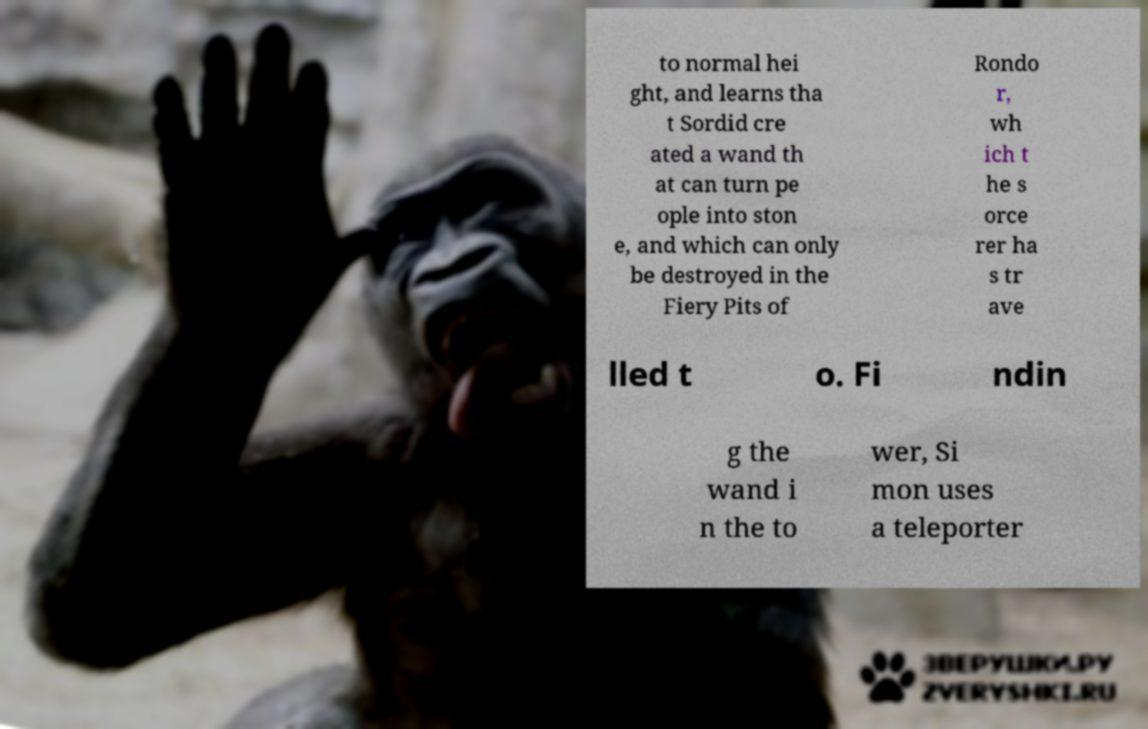What messages or text are displayed in this image? I need them in a readable, typed format. to normal hei ght, and learns tha t Sordid cre ated a wand th at can turn pe ople into ston e, and which can only be destroyed in the Fiery Pits of Rondo r, wh ich t he s orce rer ha s tr ave lled t o. Fi ndin g the wand i n the to wer, Si mon uses a teleporter 